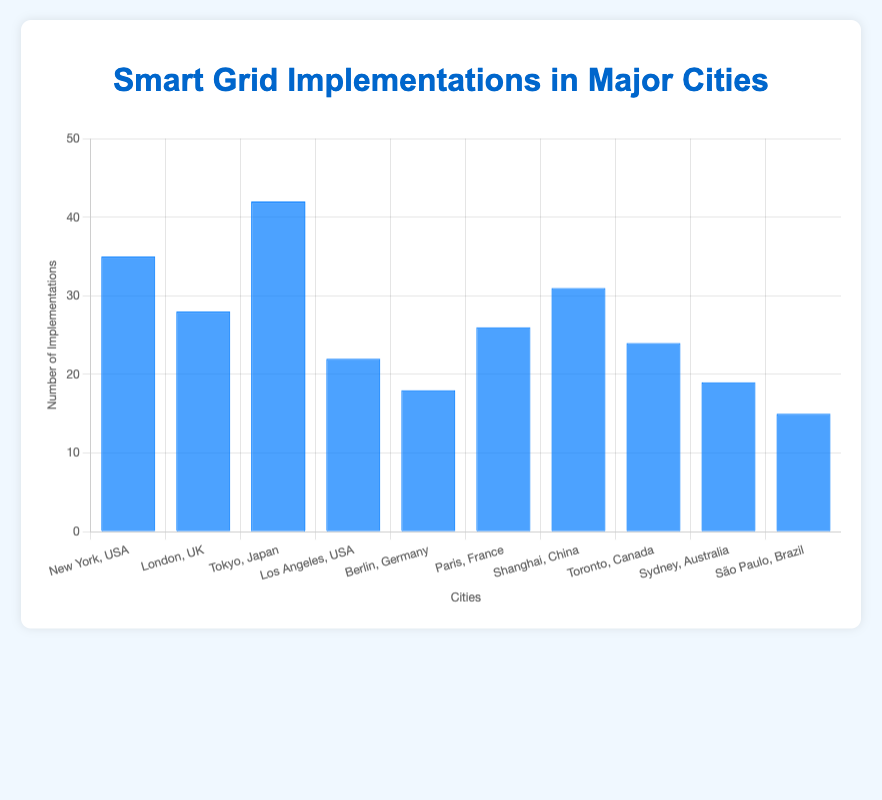What city has the highest number of smart grid implementations? The city with the highest bar will represent the city with the most implementations. Tokyo has the highest bar, indicating the most smart grid implementations.
Answer: Tokyo Which city has the lowest number of smart grid implementations? The city with the lowest bar will represent the city with the least implementations. São Paulo has the shortest bar, indicating the least smart grid implementations.
Answer: São Paulo What is the total number of smart grid implementations in USA cities shown in the chart? Summing the smart grid implementations of New York and Los Angeles (both USA cities) gives us 35 + 22.
Answer: 57 How many more smart grid implementations does Tokyo have compared to Berlin? Subtract the number of implementations in Berlin from those in Tokyo. Tokyo has 42 and Berlin has 18, so 42 - 18.
Answer: 24 What is the average number of smart grid implementations across all cities? Add up all the implementations: 35 + 28 + 42 + 22 + 18 + 26 + 31 + 24 + 19 + 15, then divide by the number of cities, which is 10.
Answer: 26 Which pair of cities have a combined total of 52 smart grid implementations? Checking each pair's combined number of implementations: New York and Los Angeles (35+22=57), London and Berlin (28+18=46), Tokyo and São Paulo (42+15=57), Berlin and Paris (18+26=44), Shanghai and Toronto (31+24=55), New York and Paris (35+26=61), Tokyo and Sydney (42+19=61), and eventually Tokyo and Los Angeles (42+22=64). Thus, none of the pairs sum up to 52.
Answer: None Which city has the second lowest number of smart grid implementations? Identify the city with the second shortest bar after São Paulo (15). Sydney is next with 19 implementations.
Answer: Sydney What is the combined number of smart grid implementations in New York, London, and Tokyo? Adding the implementations in New York (35), London (28), and Tokyo (42) gives us 35 + 28 + 42.
Answer: 105 Identify the countries represented by at least one city with more than 30 smart grid implementations. Check the countries of cities with more than 30 implementations: New York (USA), Tokyo (Japan), and Shanghai (China).
Answer: USA, Japan, China Is the number of smart grid implementations in Paris greater than in Berlin and Sydney combined? Adding the implementations in Berlin (18) and Sydney (19) gives 18 + 19 = 37. Paris has 26, which is less than 37.
Answer: No 